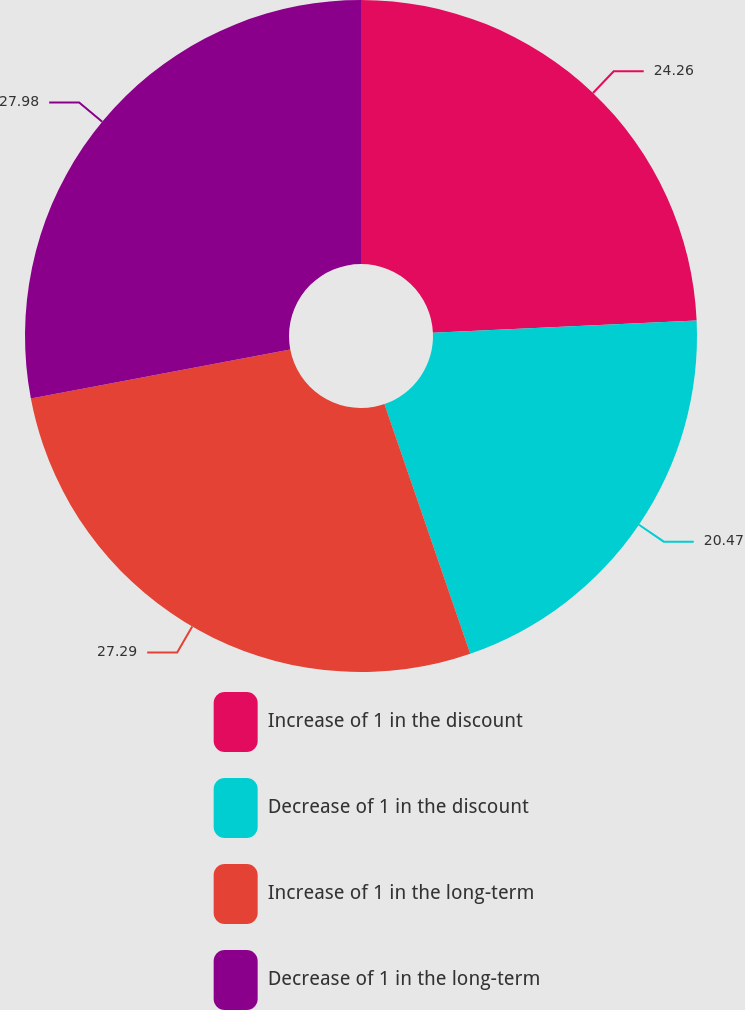<chart> <loc_0><loc_0><loc_500><loc_500><pie_chart><fcel>Increase of 1 in the discount<fcel>Decrease of 1 in the discount<fcel>Increase of 1 in the long-term<fcel>Decrease of 1 in the long-term<nl><fcel>24.26%<fcel>20.47%<fcel>27.29%<fcel>27.98%<nl></chart> 